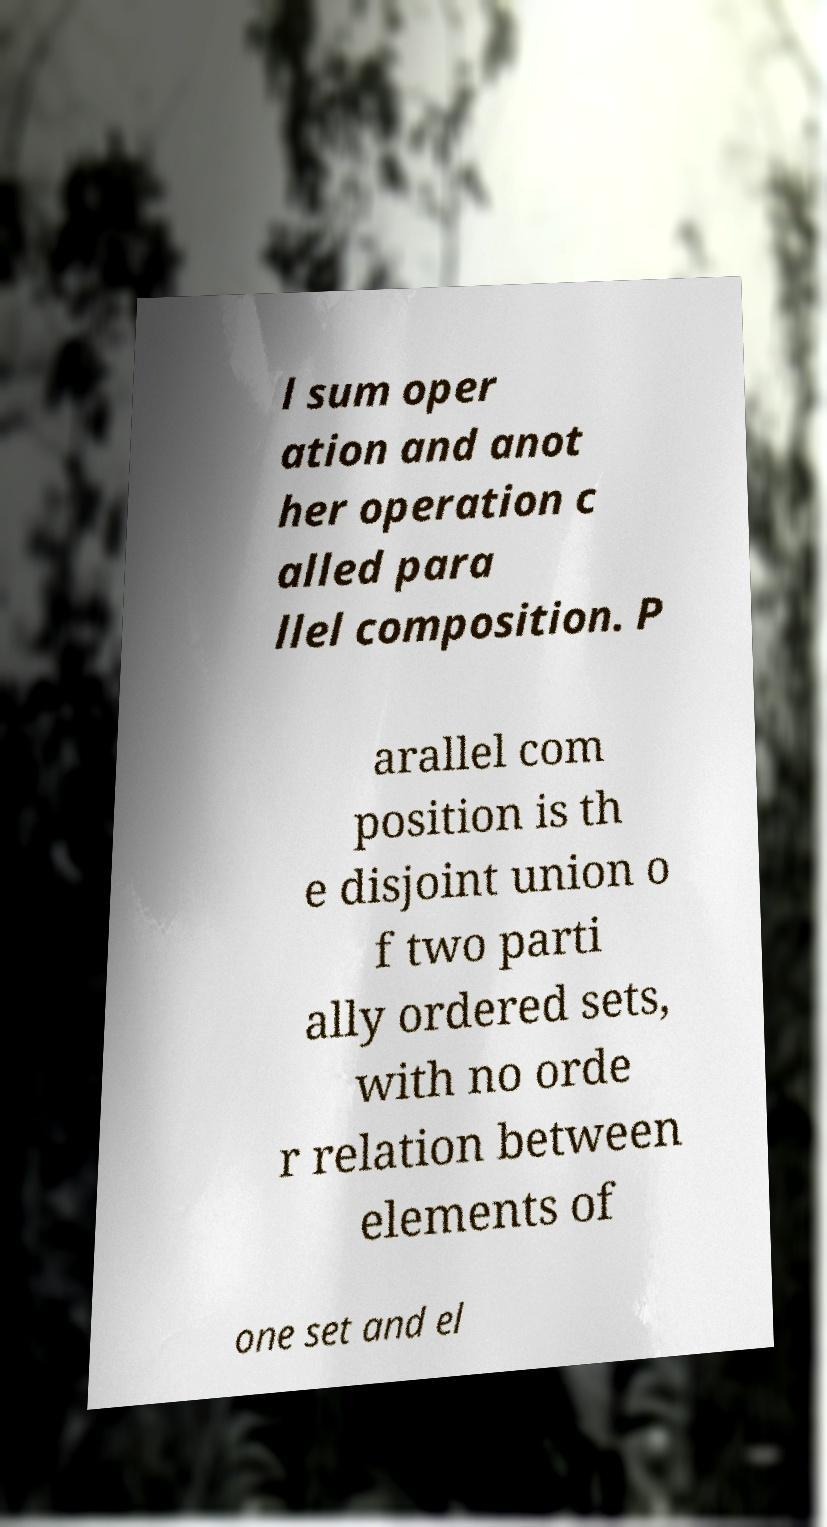Can you read and provide the text displayed in the image?This photo seems to have some interesting text. Can you extract and type it out for me? l sum oper ation and anot her operation c alled para llel composition. P arallel com position is th e disjoint union o f two parti ally ordered sets, with no orde r relation between elements of one set and el 